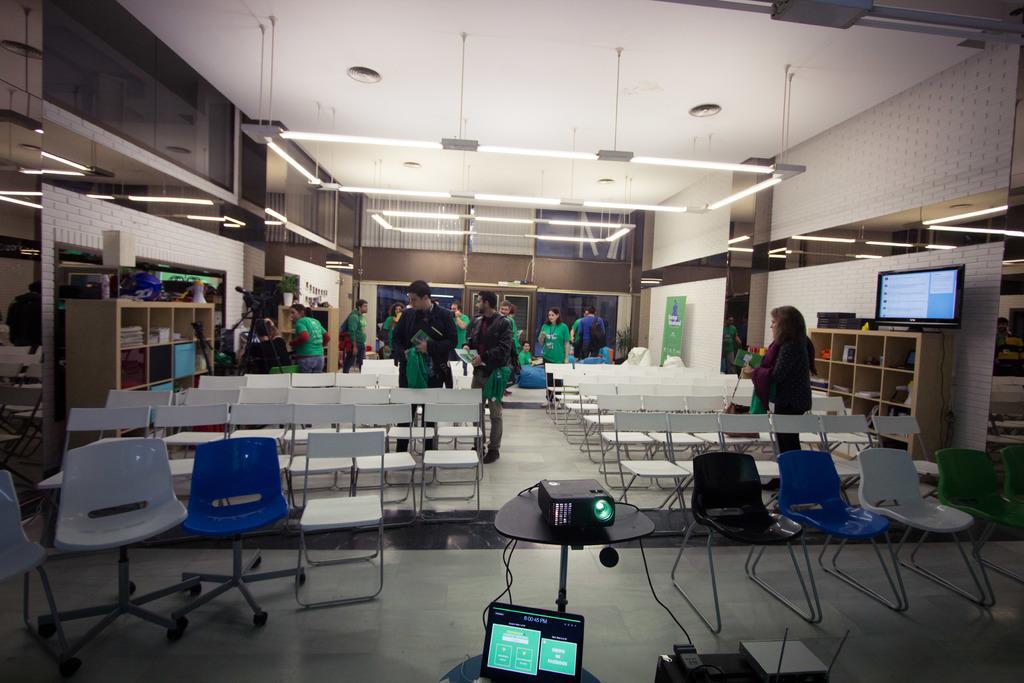In one or two sentences, can you explain what this image depicts? Few persons standing. We can see chairs and table,. On the table we can see projector. This is laptop. On the background we can see wall,cupboards,television,banner. On the top we can see lights. In the cupboard we can see books. This is floor. 